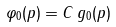<formula> <loc_0><loc_0><loc_500><loc_500>\varphi _ { 0 } ( p ) = C \, g _ { 0 } ( p )</formula> 